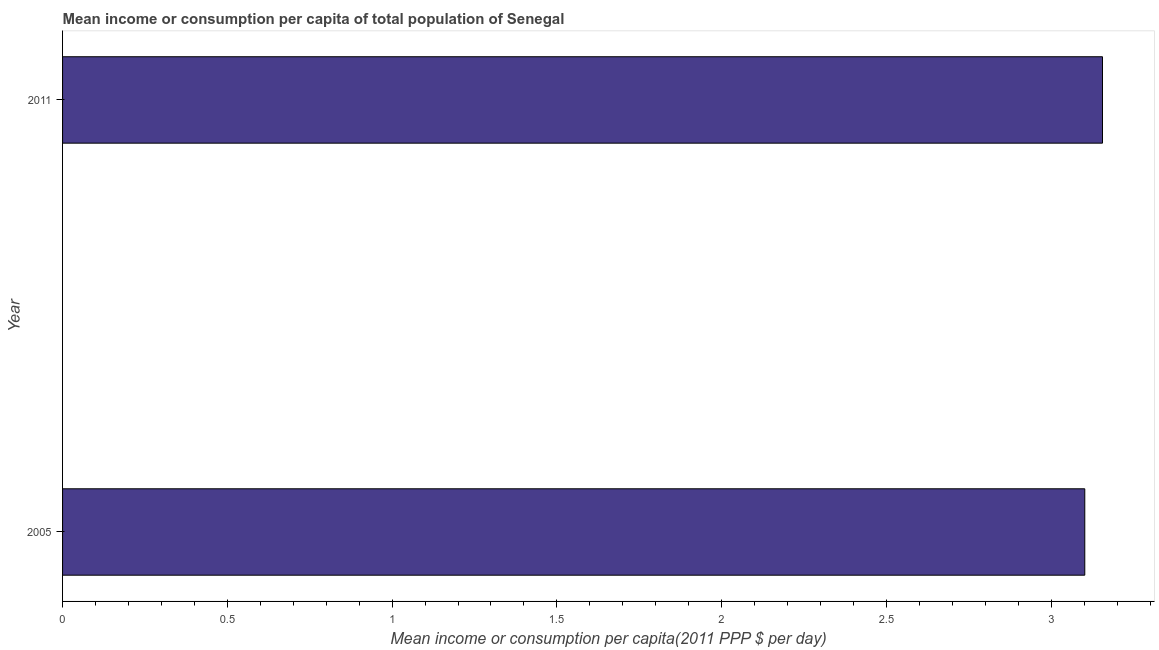Does the graph contain grids?
Make the answer very short. No. What is the title of the graph?
Offer a terse response. Mean income or consumption per capita of total population of Senegal. What is the label or title of the X-axis?
Keep it short and to the point. Mean income or consumption per capita(2011 PPP $ per day). What is the mean income or consumption in 2005?
Provide a short and direct response. 3.1. Across all years, what is the maximum mean income or consumption?
Give a very brief answer. 3.16. Across all years, what is the minimum mean income or consumption?
Ensure brevity in your answer.  3.1. In which year was the mean income or consumption minimum?
Ensure brevity in your answer.  2005. What is the sum of the mean income or consumption?
Your answer should be very brief. 6.26. What is the difference between the mean income or consumption in 2005 and 2011?
Offer a terse response. -0.05. What is the average mean income or consumption per year?
Offer a terse response. 3.13. What is the median mean income or consumption?
Provide a short and direct response. 3.13. In how many years, is the mean income or consumption greater than 1.6 $?
Make the answer very short. 2. In how many years, is the mean income or consumption greater than the average mean income or consumption taken over all years?
Your response must be concise. 1. How many bars are there?
Provide a short and direct response. 2. What is the difference between two consecutive major ticks on the X-axis?
Keep it short and to the point. 0.5. What is the Mean income or consumption per capita(2011 PPP $ per day) in 2005?
Offer a very short reply. 3.1. What is the Mean income or consumption per capita(2011 PPP $ per day) of 2011?
Give a very brief answer. 3.16. What is the difference between the Mean income or consumption per capita(2011 PPP $ per day) in 2005 and 2011?
Make the answer very short. -0.05. 